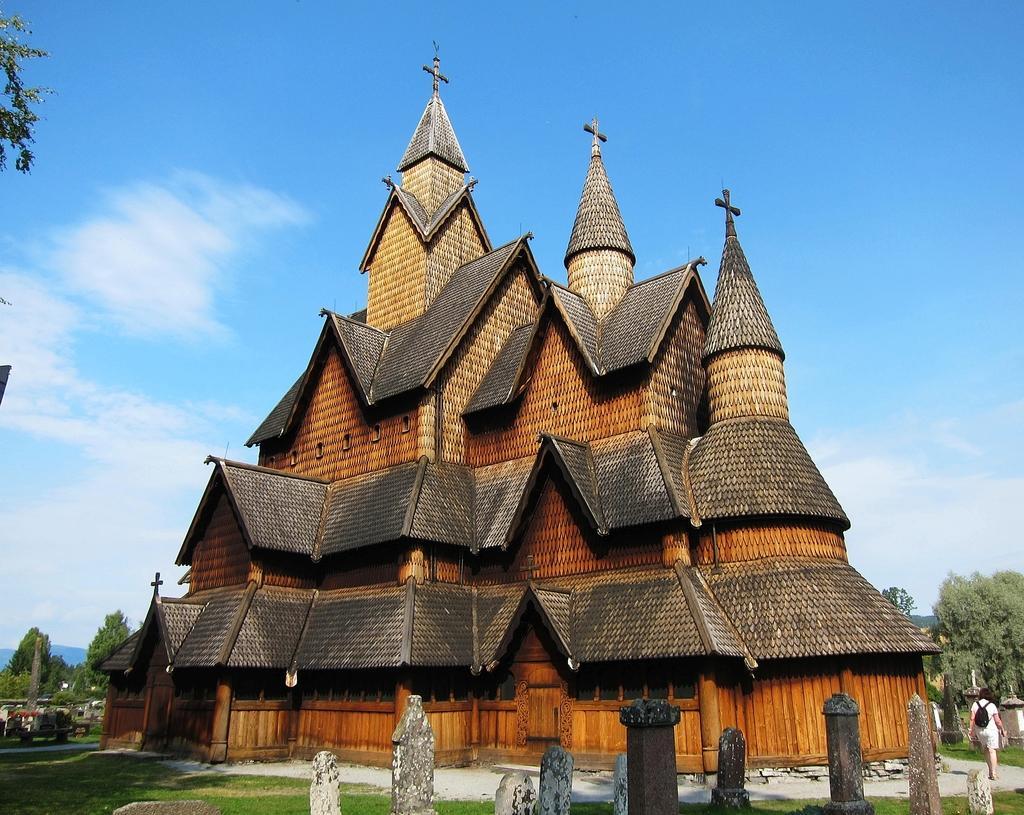Could you give a brief overview of what you see in this image? In the image we can see the cathedral and poles. We can even a person walking, wearing clothes and carrying a bag. Here we can see grass, trees and the sky 